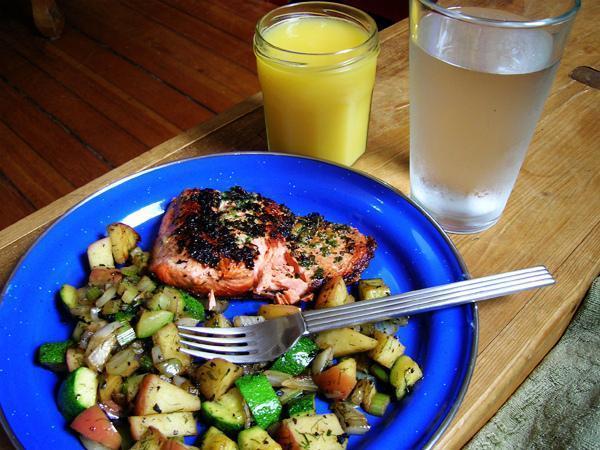How many dining tables are there?
Give a very brief answer. 1. How many cups are there?
Give a very brief answer. 2. How many buses do you see?
Give a very brief answer. 0. 